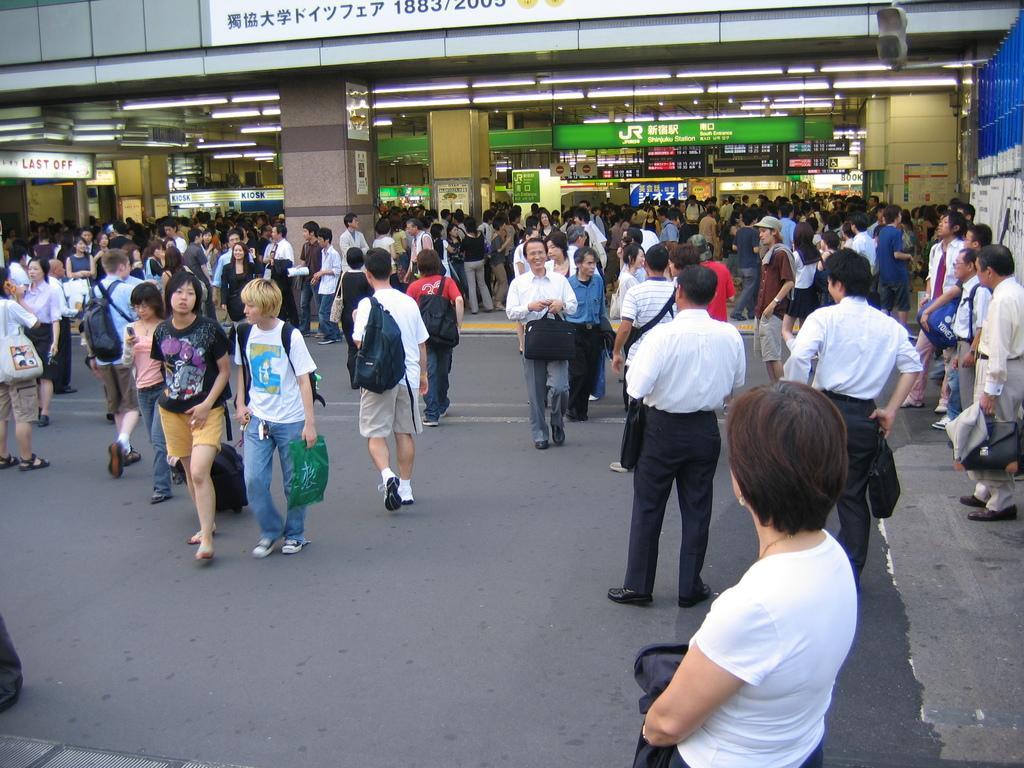How would you summarize this image in a sentence or two? In this image I can see number of people are standing on the road and I can see few of them are wearing bags. In the background I can see few pillars, few boards which are green in color and the building. 